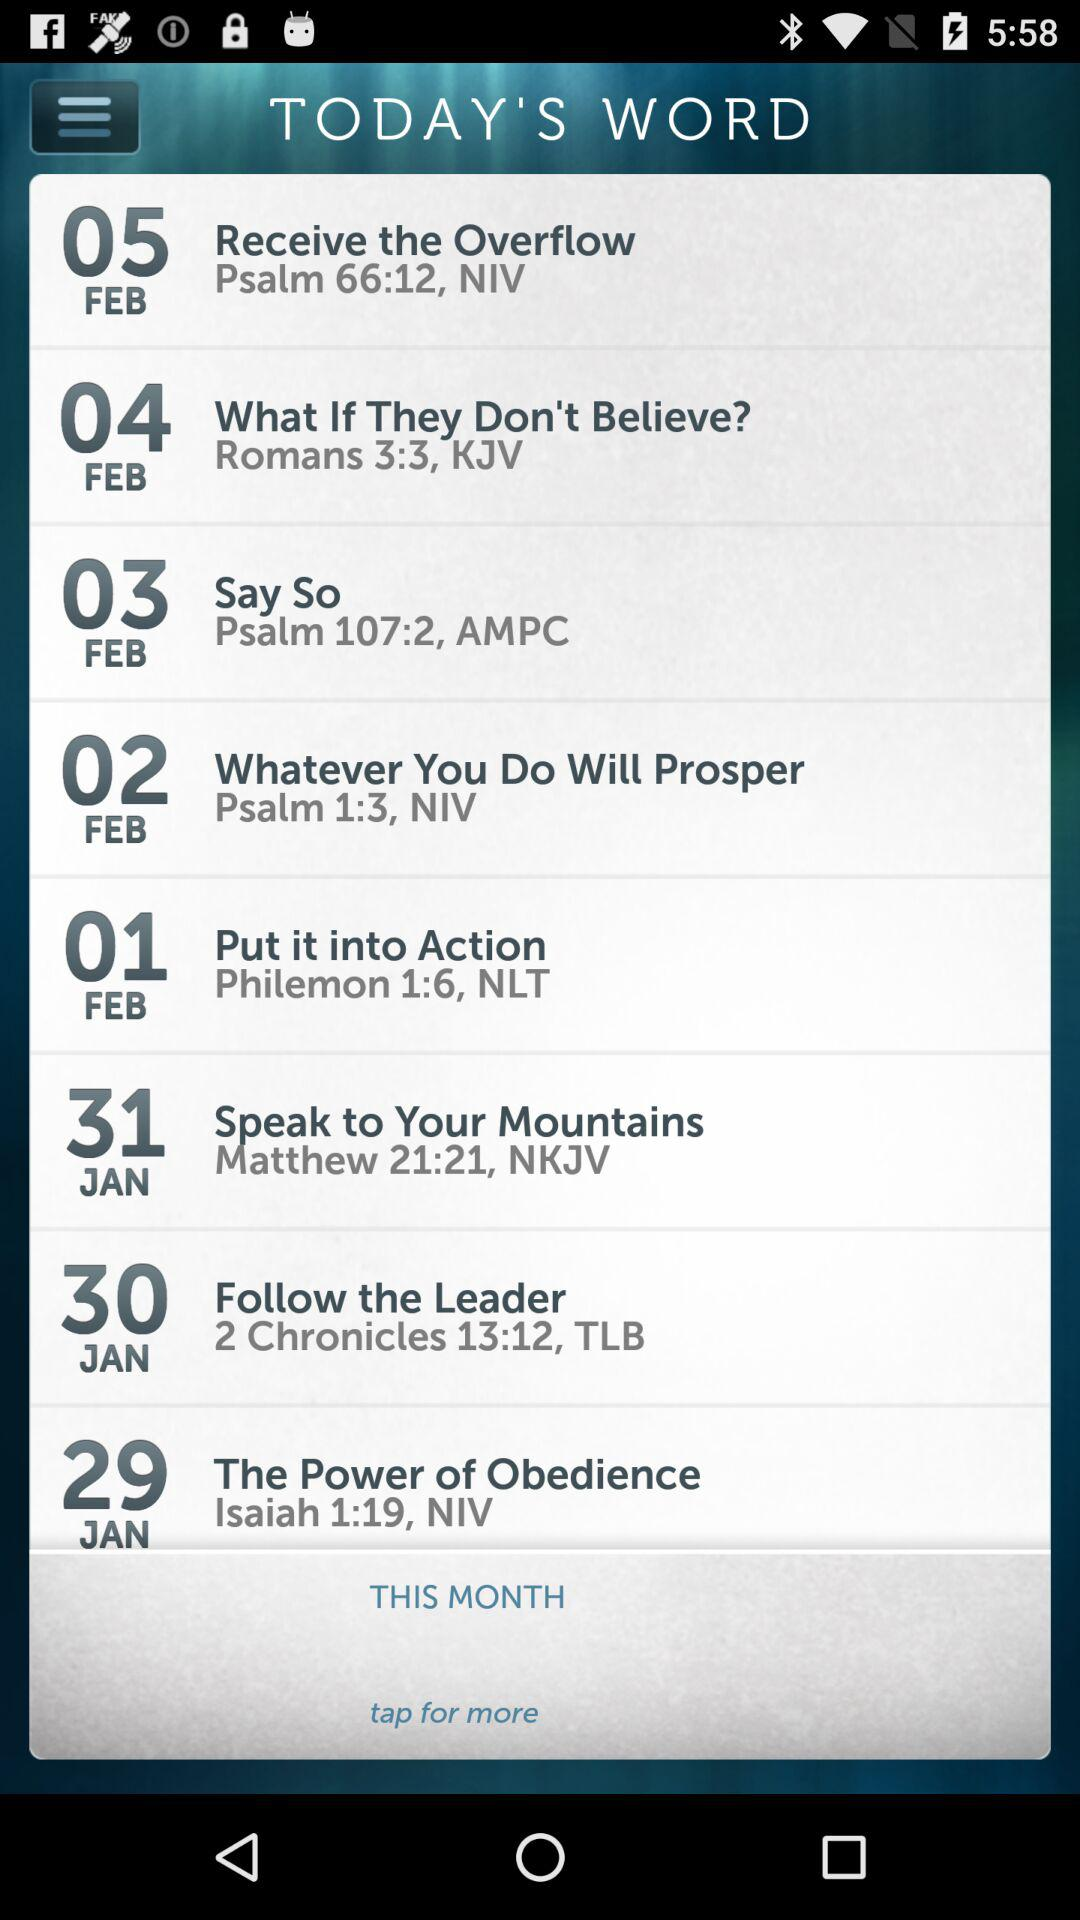What is today's word for January 30th? The word for January 30th is "Follow the Leader". 